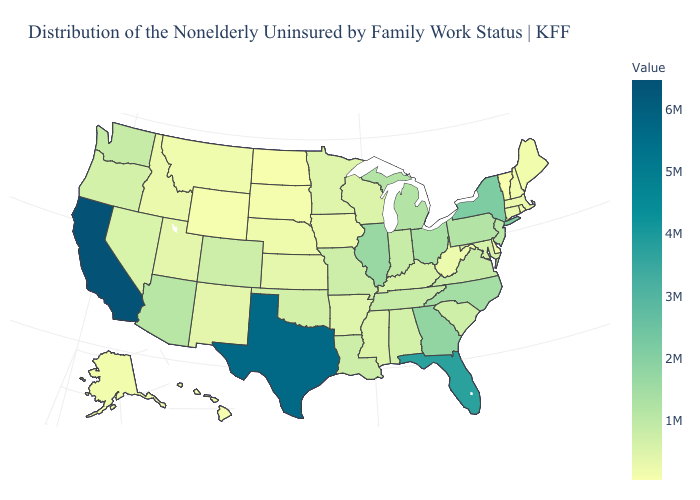Does Texas have the highest value in the South?
Write a very short answer. Yes. Does California have the highest value in the USA?
Short answer required. Yes. Does Pennsylvania have the lowest value in the Northeast?
Quick response, please. No. 